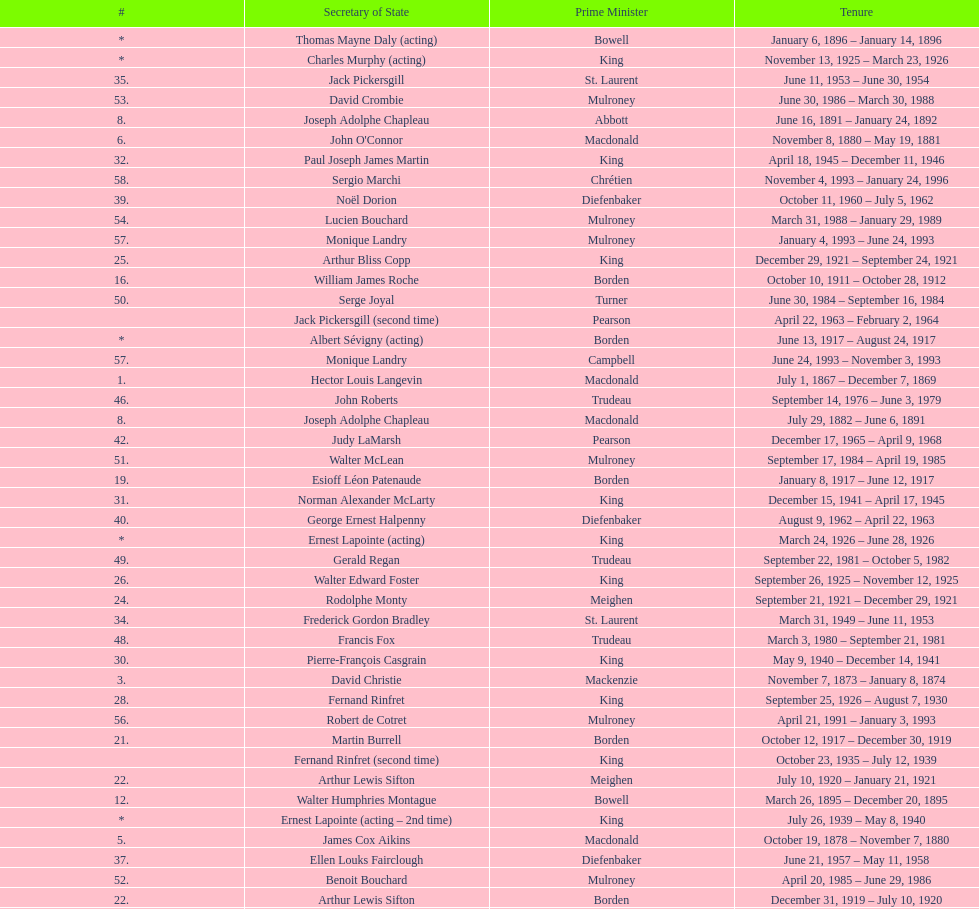Which secretary of state came after jack pkckersgill? Roch Pinard. 